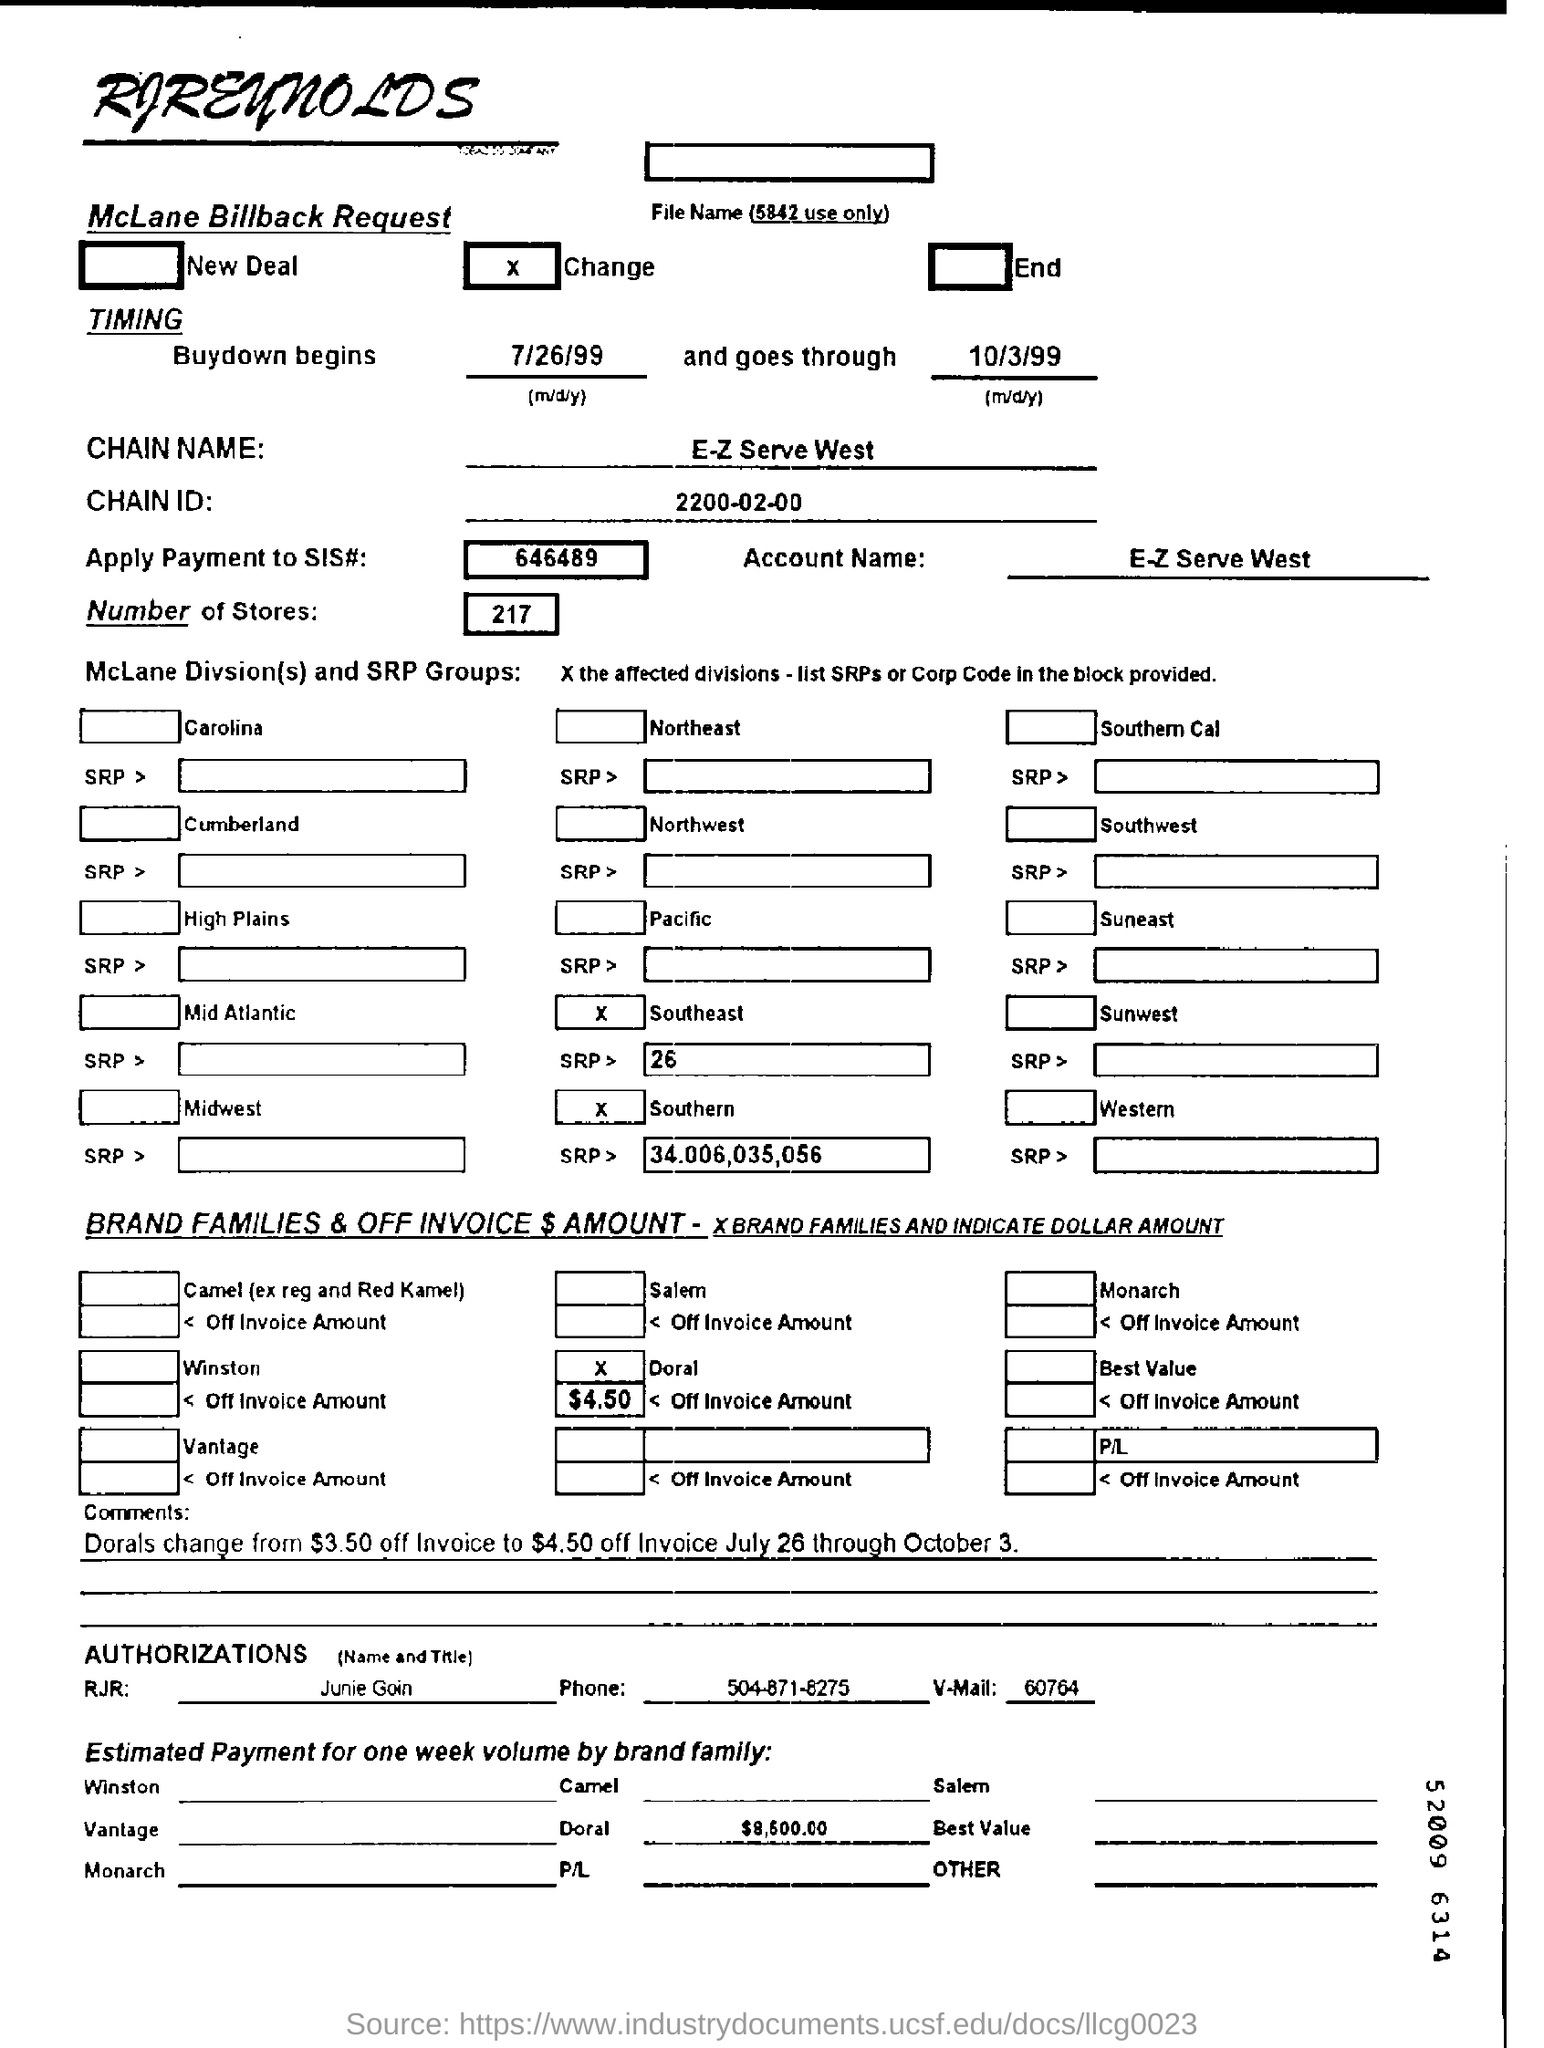How much is the estimated payment for one week volume by Doral family?
Offer a terse response. $ 8,600.00. What is the name of the chain?
Offer a very short reply. E-Z serve west. When will the buydown begin?
Keep it short and to the point. 7/26/99. How many number of stores are mentioned on the McLane billback request form?
Ensure brevity in your answer.  217. 